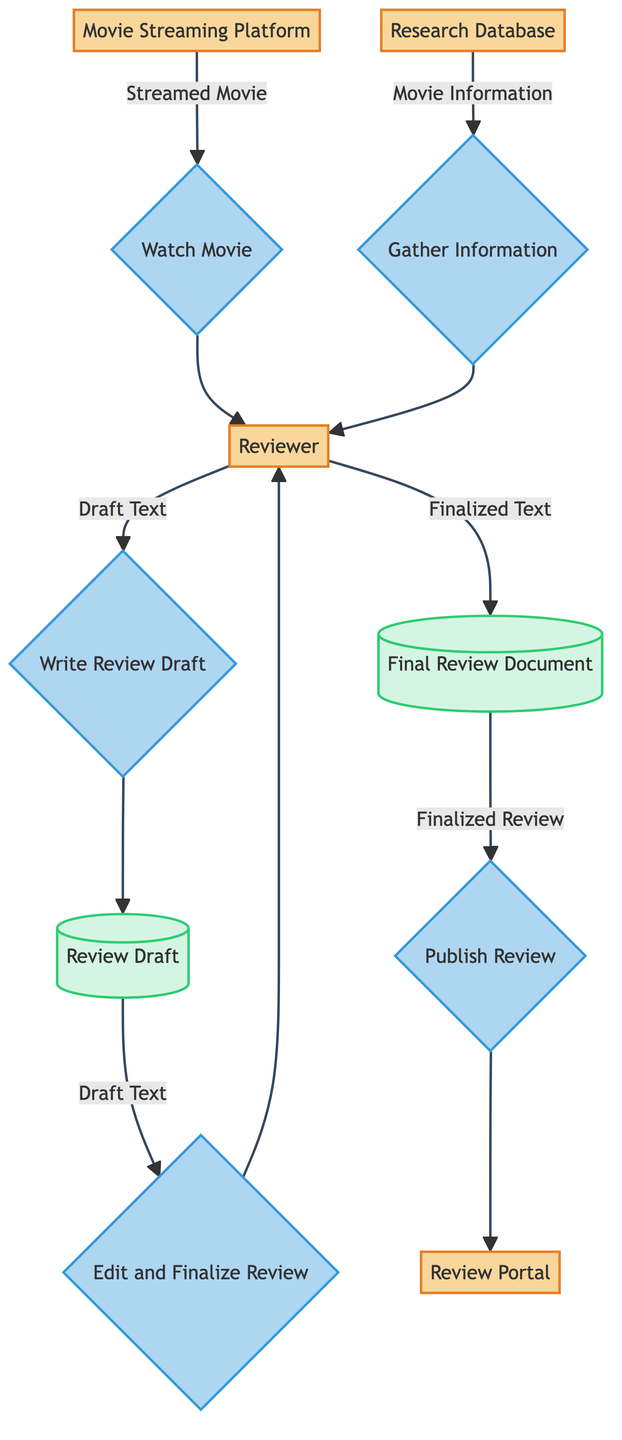What is the role of the Movie Streaming Platform in the process? The Movie Streaming Platform is the source where the reviewer streams the movie for their review process. It initiates the first step of the diagram by providing the streamed movie.
Answer: Source of streamed movie What type of entity is the Reviewer? The Reviewer is classified as an external entity in the diagram, indicating that they are not part of the internal data flow but interact with the processes and data.
Answer: External Entity How many processes are represented in the diagram? There are five distinct processes illustrated in the diagram: Watch Movie, Gather Information, Write Review Draft, Edit and Finalize Review, and Publish Review.
Answer: Five processes What content does the Research Database provide to the Reviewer? The Research Database provides Movie Information, which assists the Reviewer in gathering relevant details necessary for writing the review.
Answer: Movie Information Which data flow feeds into the Review Draft? The data flow that feeds into the Review Draft comes from the Reviewer when they write the draft text of the movie review after watching the movie and gathering information.
Answer: Draft Text What happens after the Reviewer edits and finalizes the review? After editing and finalizing the review, the Reviewer proceeds to store the finalized text into the Final Review Document, which is the next node in the flow.
Answer: Stored in Final Review Document What is the output of the Final Review Document? The output from the Final Review Document is the Finalized Review, which is then published on the Review Portal as the last step of the process.
Answer: Finalized Review Which process comes after the "Write Review Draft"? The process that follows "Write Review Draft" is "Edit and Finalize Review," where the reviewer revises and prepares the draft for publication.
Answer: Edit and Finalize Review How does the Reviewer gather movie information? The Reviewer gathers movie information by utilizing the Research Database, which provides supplementary information related to movies, directors, and actors.
Answer: Utilizing Research Database 